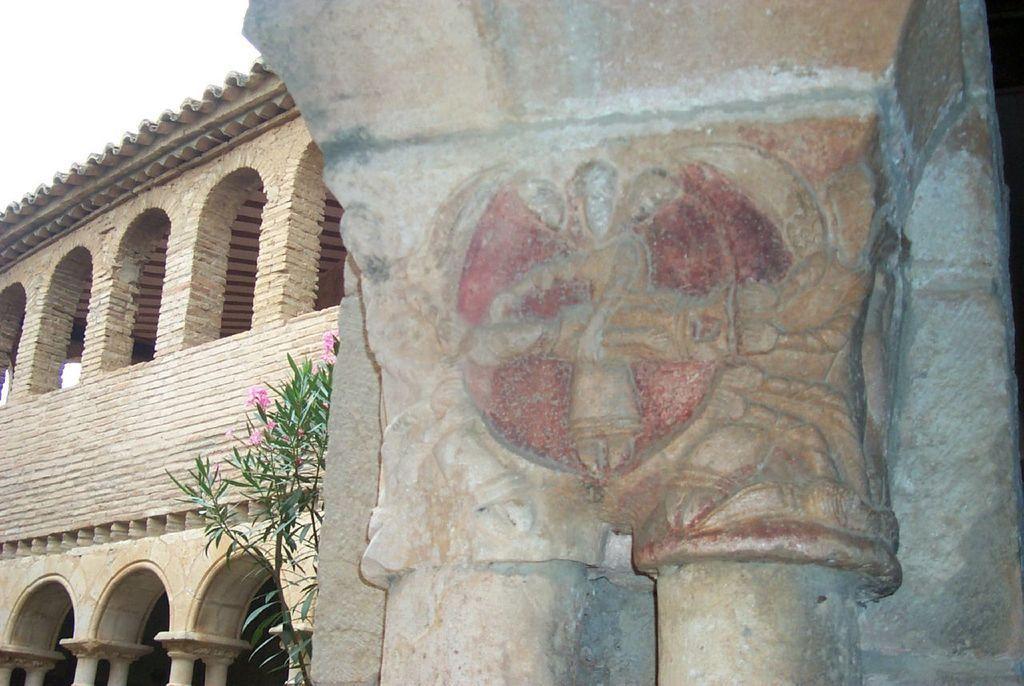Describe this image in one or two sentences. In this image I can see few designs on the wall. On the left side of this image I can see a plant and a building. 